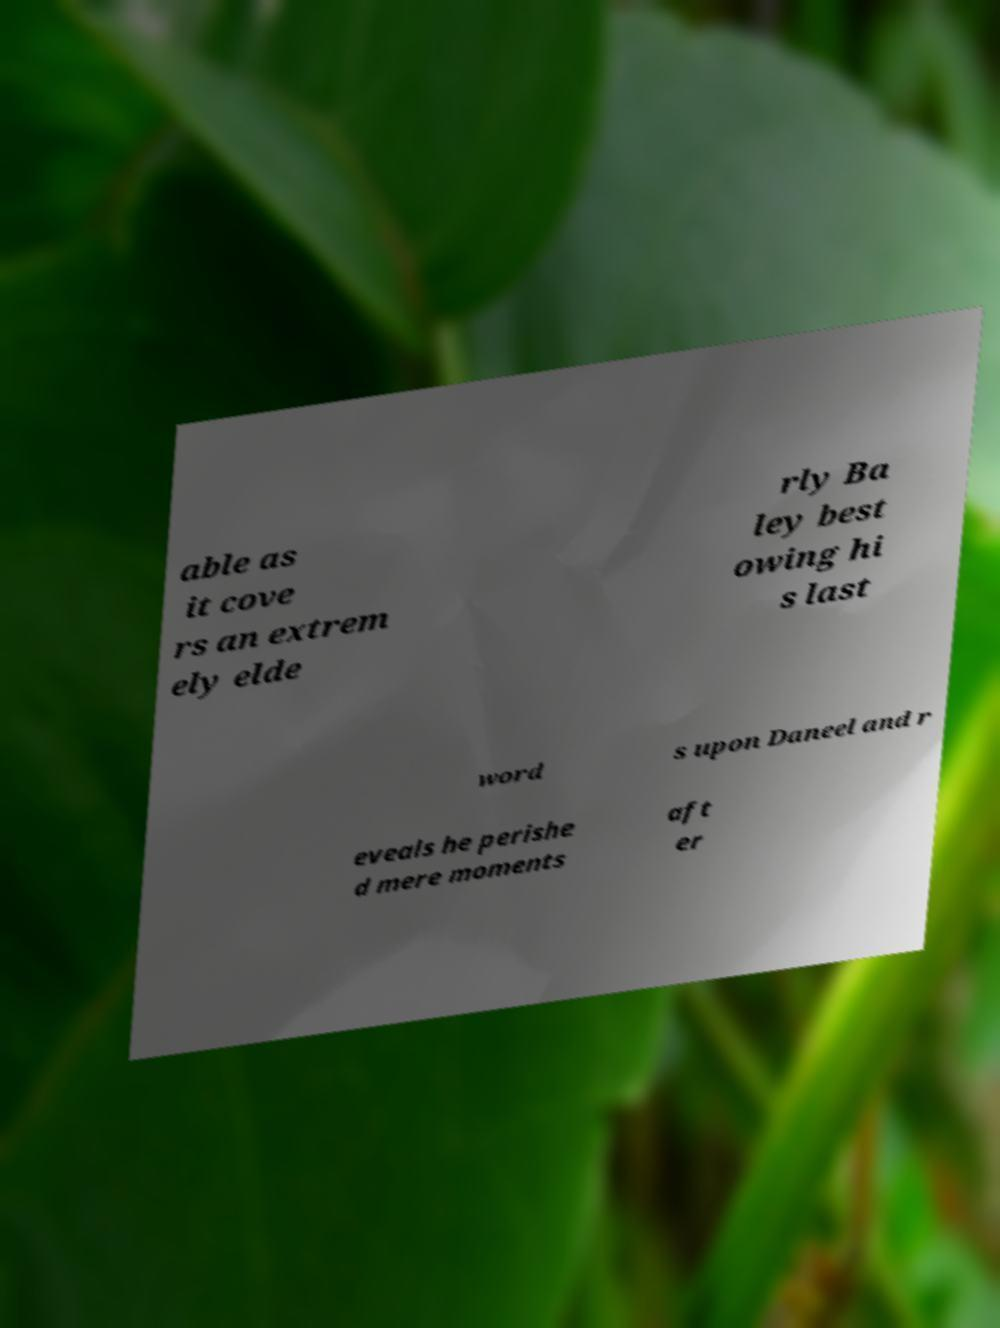I need the written content from this picture converted into text. Can you do that? able as it cove rs an extrem ely elde rly Ba ley best owing hi s last word s upon Daneel and r eveals he perishe d mere moments aft er 